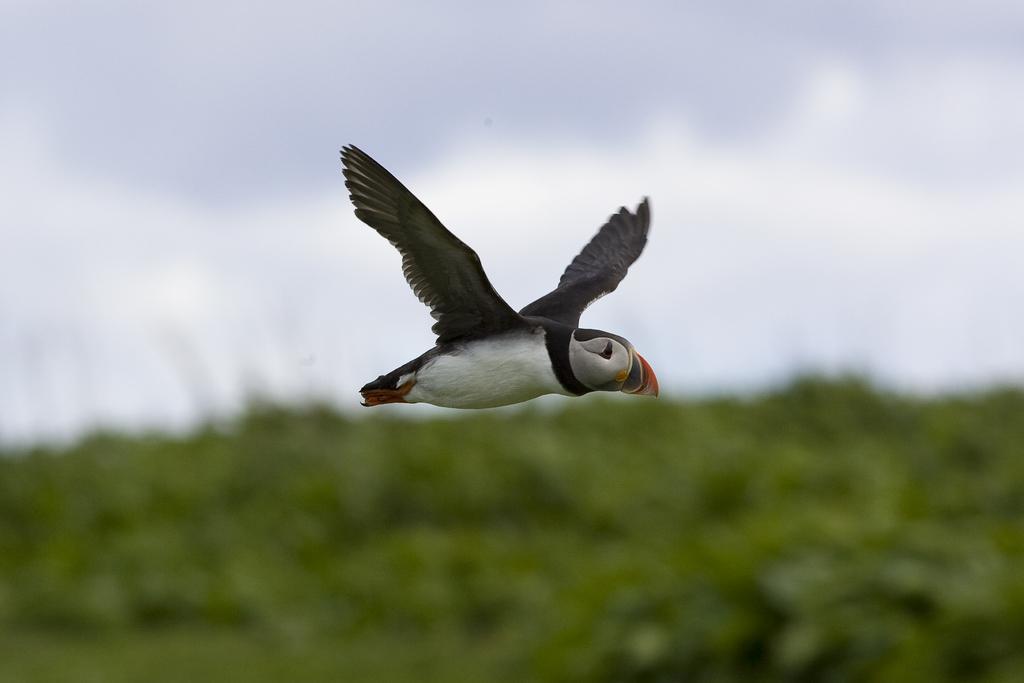How would you summarize this image in a sentence or two? In the foreground of this image, there is a bird flying in the air. On the bottom, there is greenery and on the top, there is the sky and the cloud. 